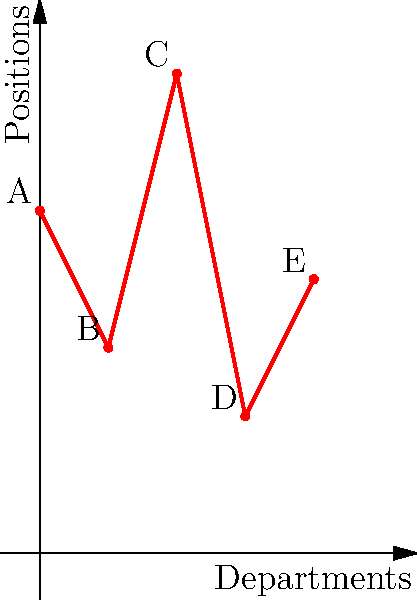As a local business owner offering internships, you've decided to distribute internship positions across five departments (A, B, C, D, and E) as shown in the graph. If we represent this distribution as a vector $\mathbf{v} = [5, 3, 7, 2, 4]$, and you want to increase the number of positions in departments B and D by 2 each while reducing the positions in departments A and E by 1 each, what would be the resulting vector $\mathbf{w}$? Also, calculate the magnitude of the difference vector $\mathbf{w} - \mathbf{v}$. Let's approach this step-by-step:

1) The initial vector is $\mathbf{v} = [5, 3, 7, 2, 4]$.

2) We need to make the following changes:
   - Increase B (2nd element) by 2
   - Increase D (4th element) by 2
   - Decrease A (1st element) by 1
   - Decrease E (5th element) by 1
   - C (3rd element) remains unchanged

3) After these changes, the new vector $\mathbf{w}$ will be:
   $\mathbf{w} = [4, 5, 7, 4, 3]$

4) To find the magnitude of $\mathbf{w} - \mathbf{v}$, we first calculate $\mathbf{w} - \mathbf{v}$:
   $\mathbf{w} - \mathbf{v} = [4, 5, 7, 4, 3] - [5, 3, 7, 2, 4] = [-1, 2, 0, 2, -1]$

5) The magnitude of a vector $[a, b, c, d, e]$ is given by $\sqrt{a^2 + b^2 + c^2 + d^2 + e^2}$

6) Therefore, the magnitude of $\mathbf{w} - \mathbf{v}$ is:
   $\sqrt{(-1)^2 + 2^2 + 0^2 + 2^2 + (-1)^2} = \sqrt{1 + 4 + 0 + 4 + 1} = \sqrt{10} = \sqrt{2}\sqrt{5}$
Answer: $\mathbf{w} = [4, 5, 7, 4, 3]$, $|\mathbf{w} - \mathbf{v}| = \sqrt{10} = \sqrt{2}\sqrt{5}$ 